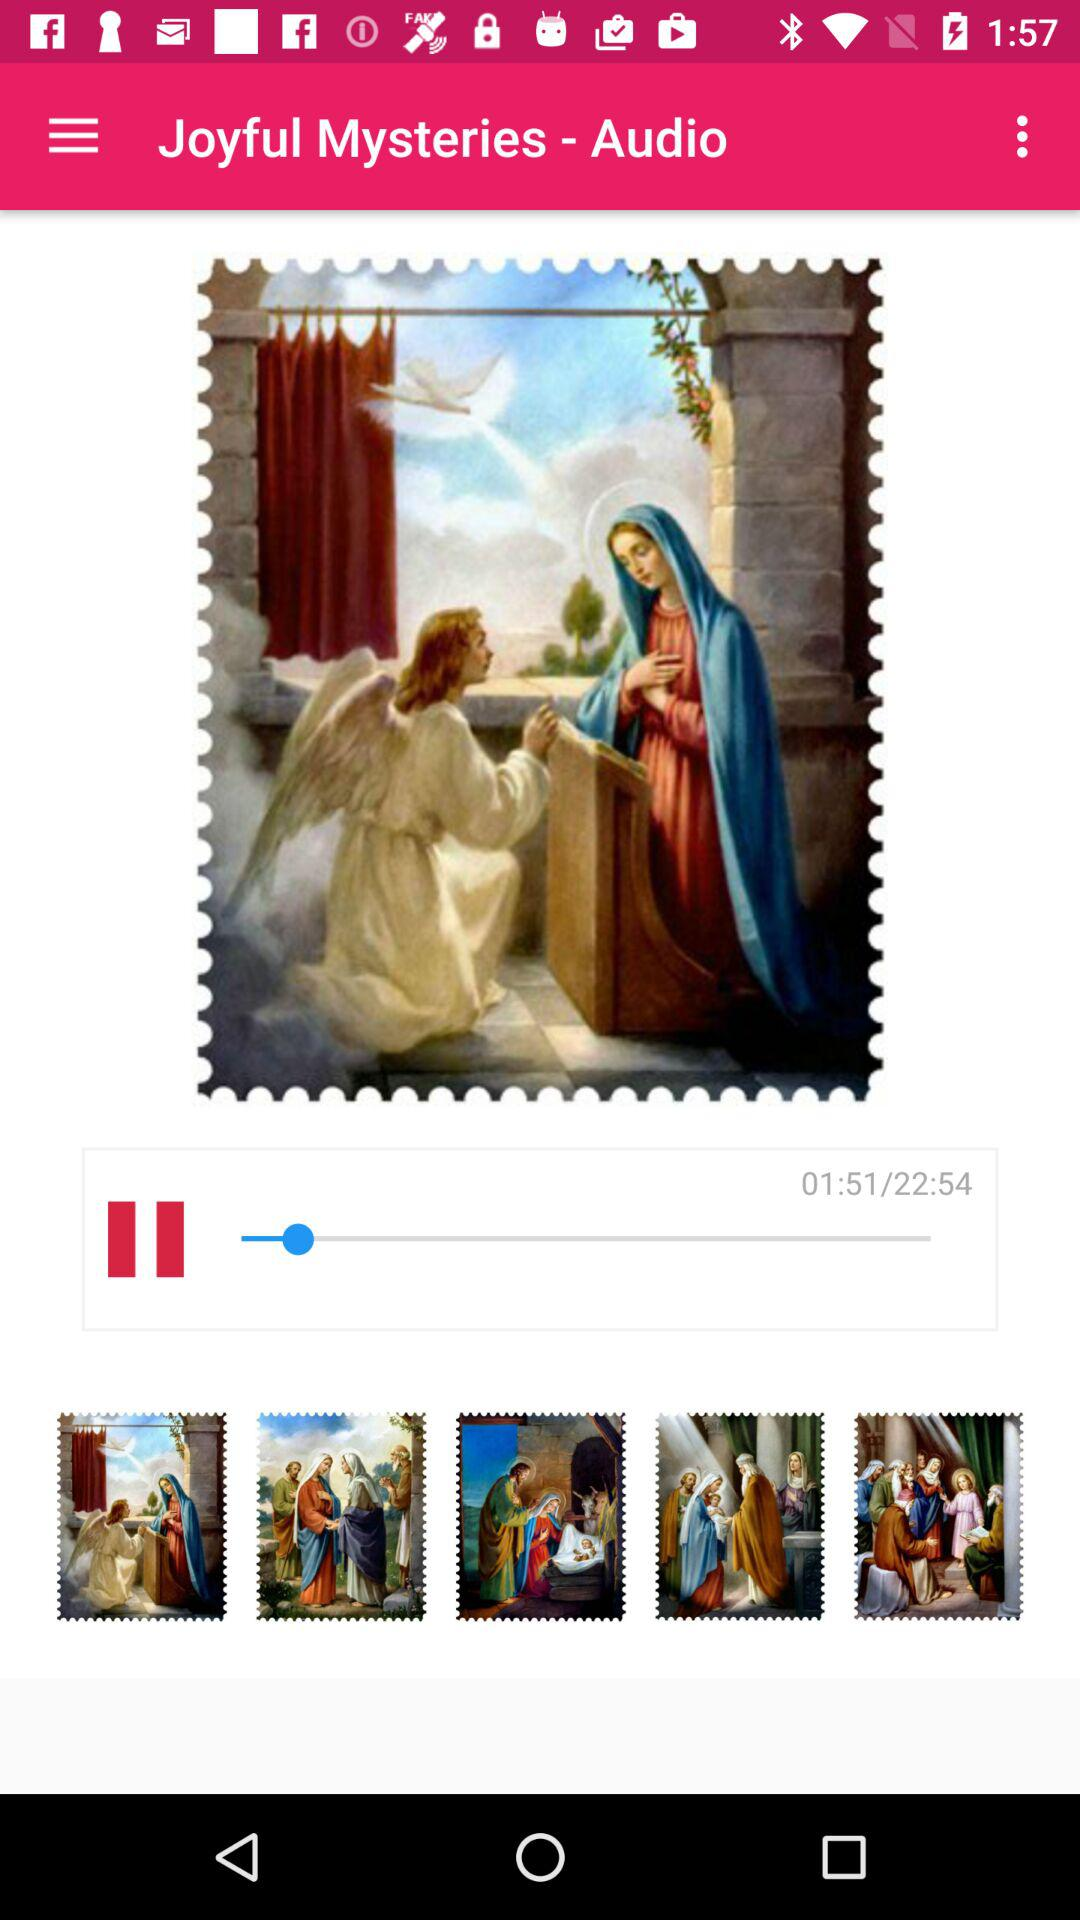For how long has the "Joyful Mysteries" audio been played? The "Joyful Mysteries" audio has been played for 1 minute and 51 seconds. 